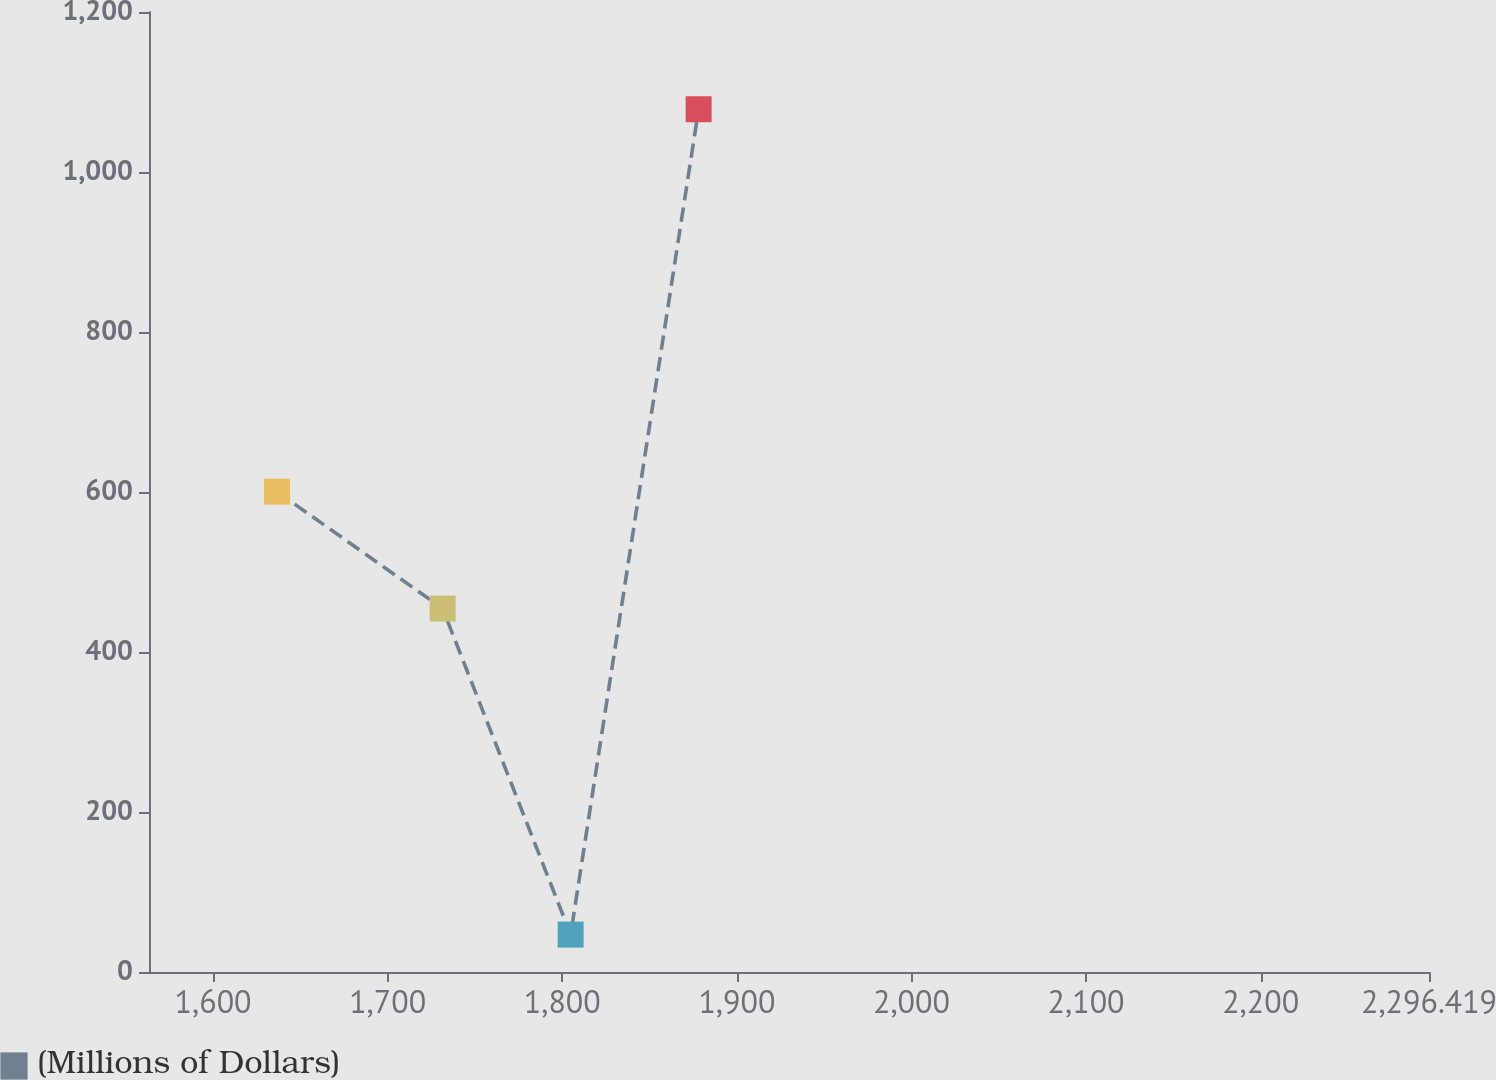<chart> <loc_0><loc_0><loc_500><loc_500><line_chart><ecel><fcel>(Millions of Dollars)<nl><fcel>1636.62<fcel>600.44<nl><fcel>1731.49<fcel>454.32<nl><fcel>1804.8<fcel>46.75<nl><fcel>1878.11<fcel>1078.44<nl><fcel>2369.73<fcel>304.47<nl></chart> 